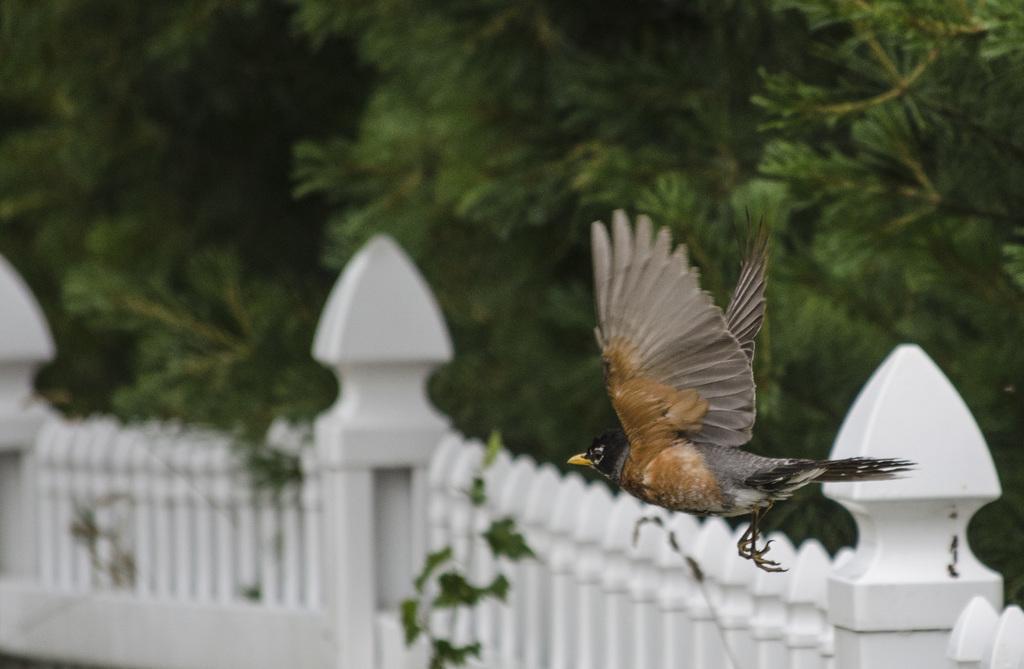In one or two sentences, can you explain what this image depicts? In this image there is a bird flying in the air , and in the background there is a kind of fence, trees. 